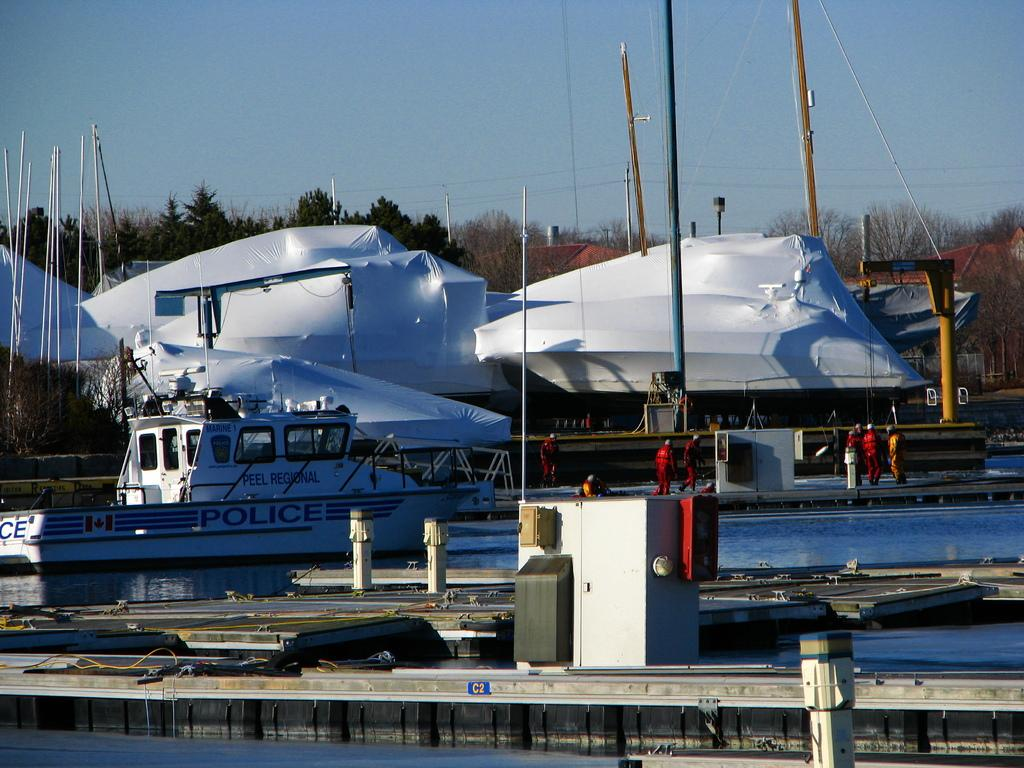<image>
Write a terse but informative summary of the picture. A police boat is docked at a marina. 